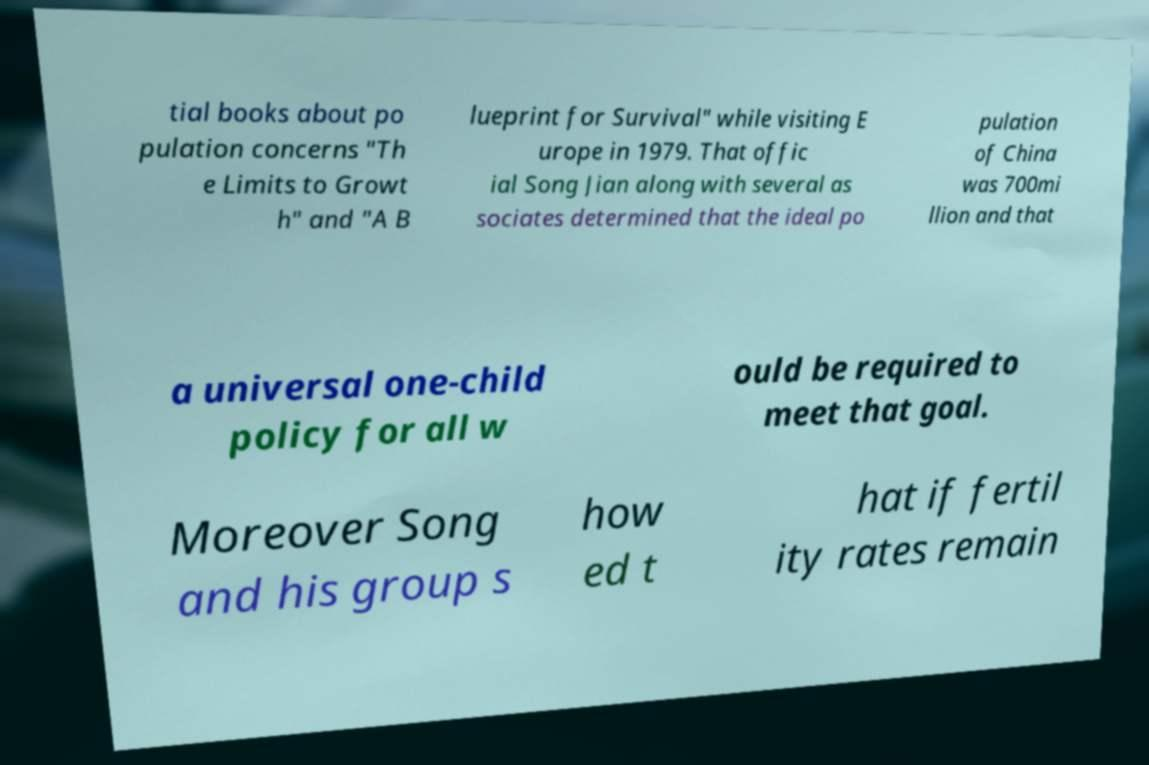Can you read and provide the text displayed in the image?This photo seems to have some interesting text. Can you extract and type it out for me? tial books about po pulation concerns "Th e Limits to Growt h" and "A B lueprint for Survival" while visiting E urope in 1979. That offic ial Song Jian along with several as sociates determined that the ideal po pulation of China was 700mi llion and that a universal one-child policy for all w ould be required to meet that goal. Moreover Song and his group s how ed t hat if fertil ity rates remain 